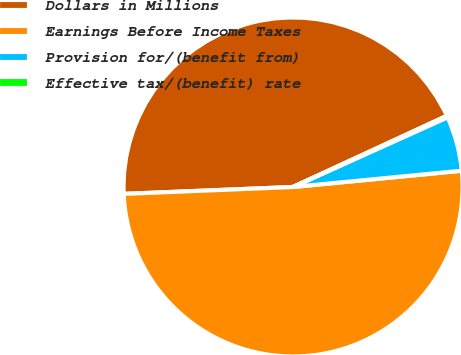<chart> <loc_0><loc_0><loc_500><loc_500><pie_chart><fcel>Dollars in Millions<fcel>Earnings Before Income Taxes<fcel>Provision for/(benefit from)<fcel>Effective tax/(benefit) rate<nl><fcel>43.75%<fcel>50.88%<fcel>5.22%<fcel>0.15%<nl></chart> 